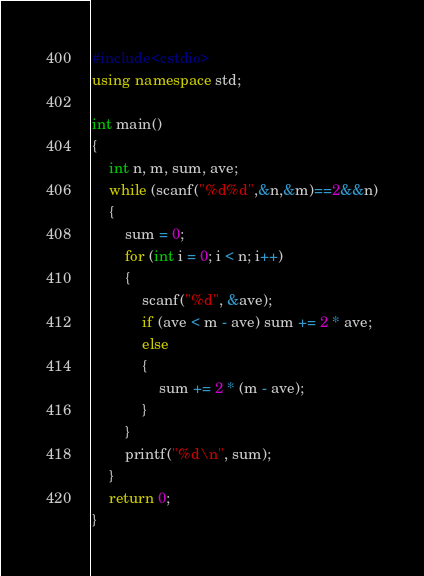Convert code to text. <code><loc_0><loc_0><loc_500><loc_500><_C++_>#include<cstdio>
using namespace std;

int main()
{
	int n, m, sum, ave;
	while (scanf("%d%d",&n,&m)==2&&n)
	{
		sum = 0;
		for (int i = 0; i < n; i++)
		{
			scanf("%d", &ave);
			if (ave < m - ave) sum += 2 * ave;
			else
			{
				sum += 2 * (m - ave);
			}
		}
		printf("%d\n", sum);
	}
	return 0;
}</code> 